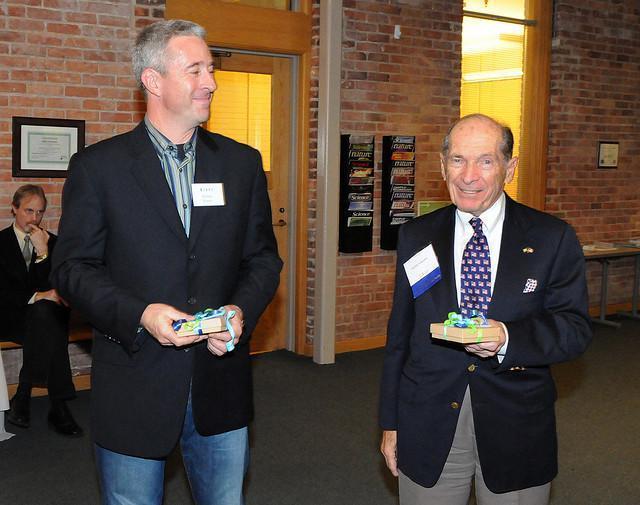How many people are wearing a tie?
Give a very brief answer. 2. How many people can be seen?
Give a very brief answer. 3. How many horses are grazing?
Give a very brief answer. 0. 